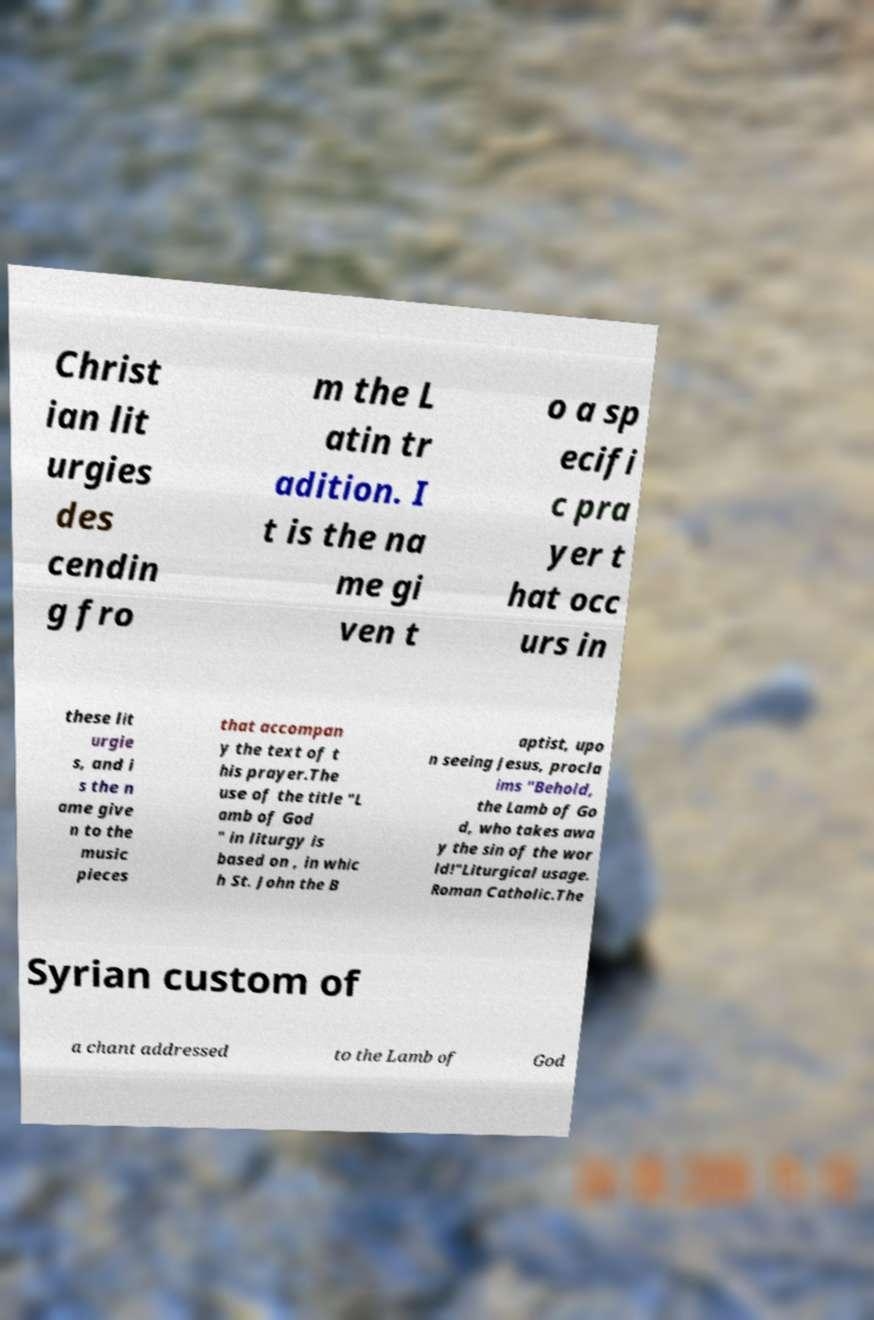Could you extract and type out the text from this image? Christ ian lit urgies des cendin g fro m the L atin tr adition. I t is the na me gi ven t o a sp ecifi c pra yer t hat occ urs in these lit urgie s, and i s the n ame give n to the music pieces that accompan y the text of t his prayer.The use of the title "L amb of God " in liturgy is based on , in whic h St. John the B aptist, upo n seeing Jesus, procla ims "Behold, the Lamb of Go d, who takes awa y the sin of the wor ld!"Liturgical usage. Roman Catholic.The Syrian custom of a chant addressed to the Lamb of God 